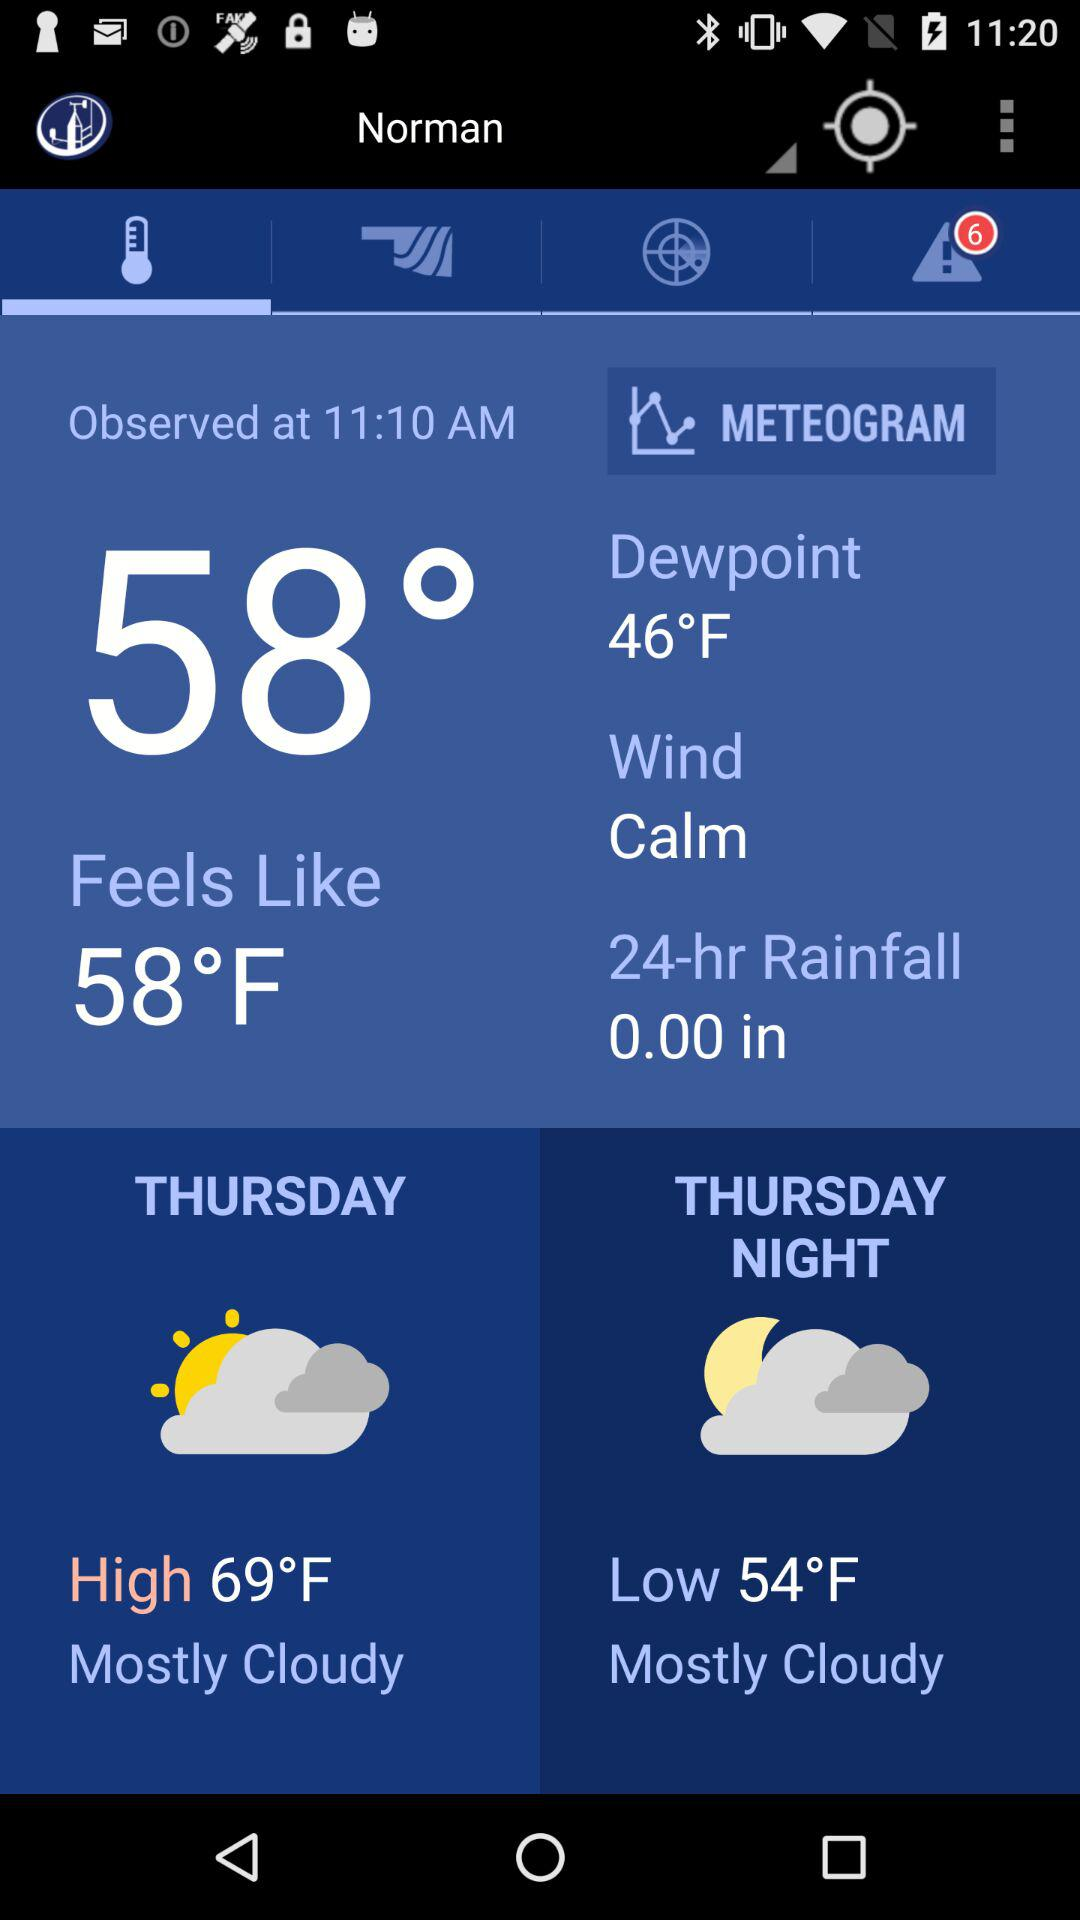When will the temperature be 54 degrees Fahrenheit? The temperature will be 54 degrees Fahrenheit on Thursday night. 